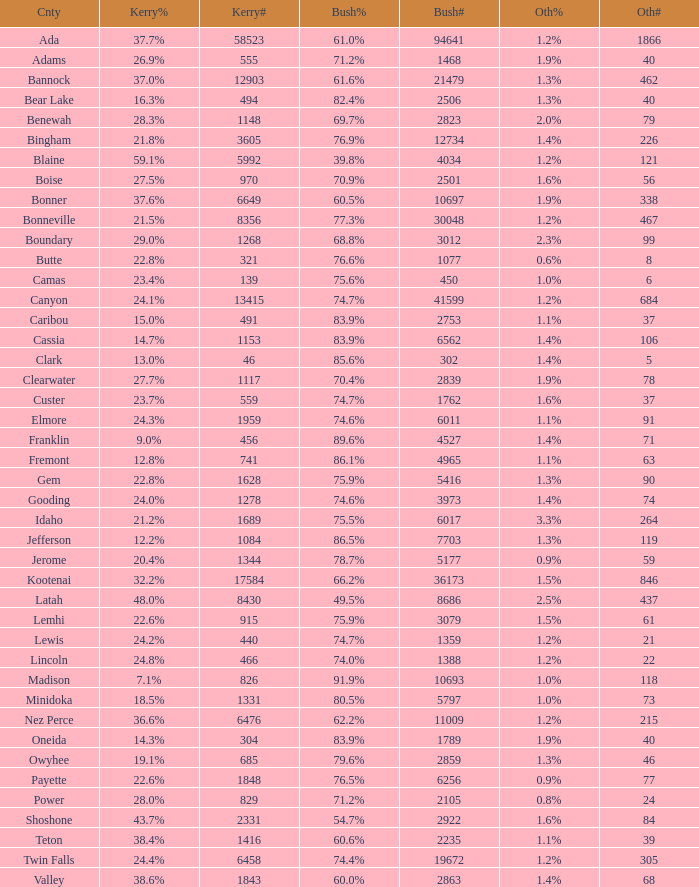How many different counts of the votes for Bush are there in the county where he got 69.7% of the votes? 1.0. 